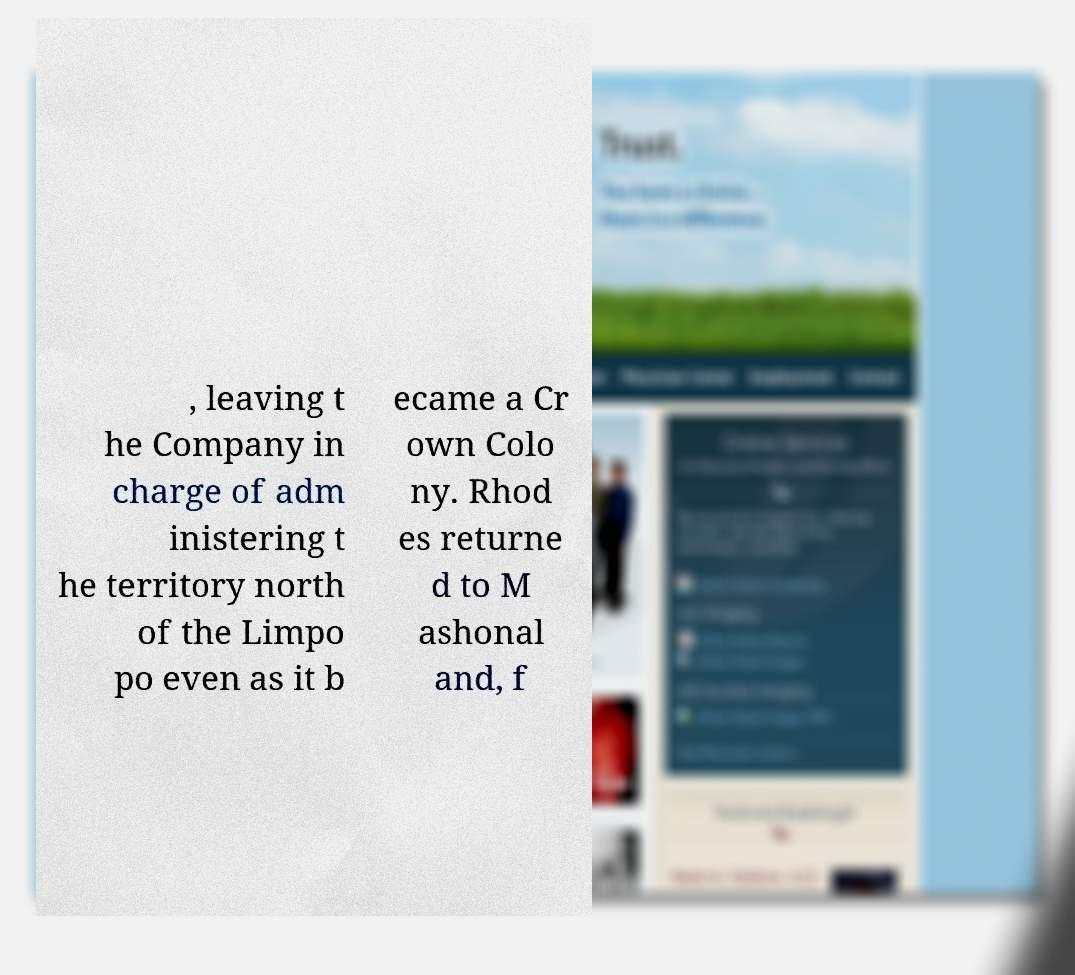For documentation purposes, I need the text within this image transcribed. Could you provide that? , leaving t he Company in charge of adm inistering t he territory north of the Limpo po even as it b ecame a Cr own Colo ny. Rhod es returne d to M ashonal and, f 